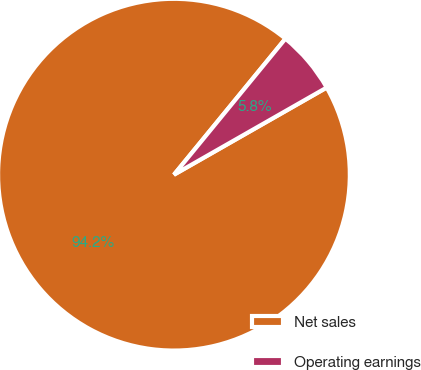Convert chart. <chart><loc_0><loc_0><loc_500><loc_500><pie_chart><fcel>Net sales<fcel>Operating earnings<nl><fcel>94.18%<fcel>5.82%<nl></chart> 